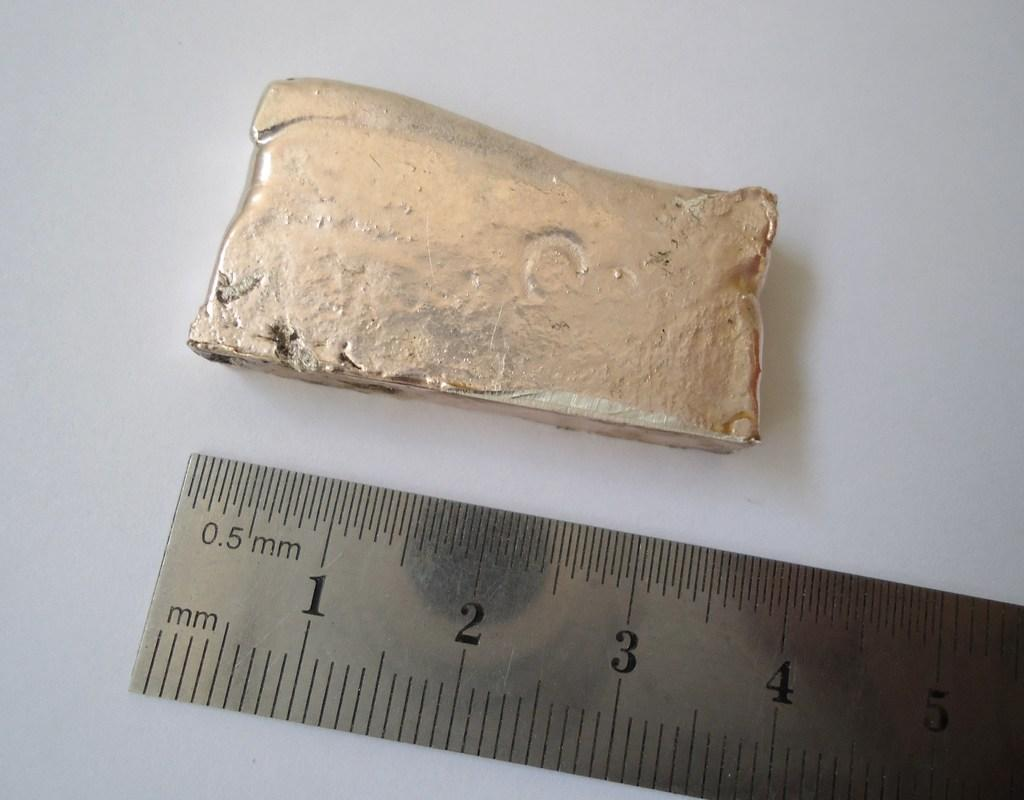<image>
Summarize the visual content of the image. An item is being measured and the length is 3 inches. 